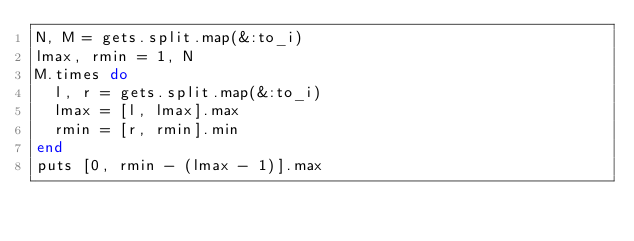Convert code to text. <code><loc_0><loc_0><loc_500><loc_500><_Ruby_>N, M = gets.split.map(&:to_i)
lmax, rmin = 1, N
M.times do
  l, r = gets.split.map(&:to_i)
  lmax = [l, lmax].max
  rmin = [r, rmin].min
end
puts [0, rmin - (lmax - 1)].max
</code> 